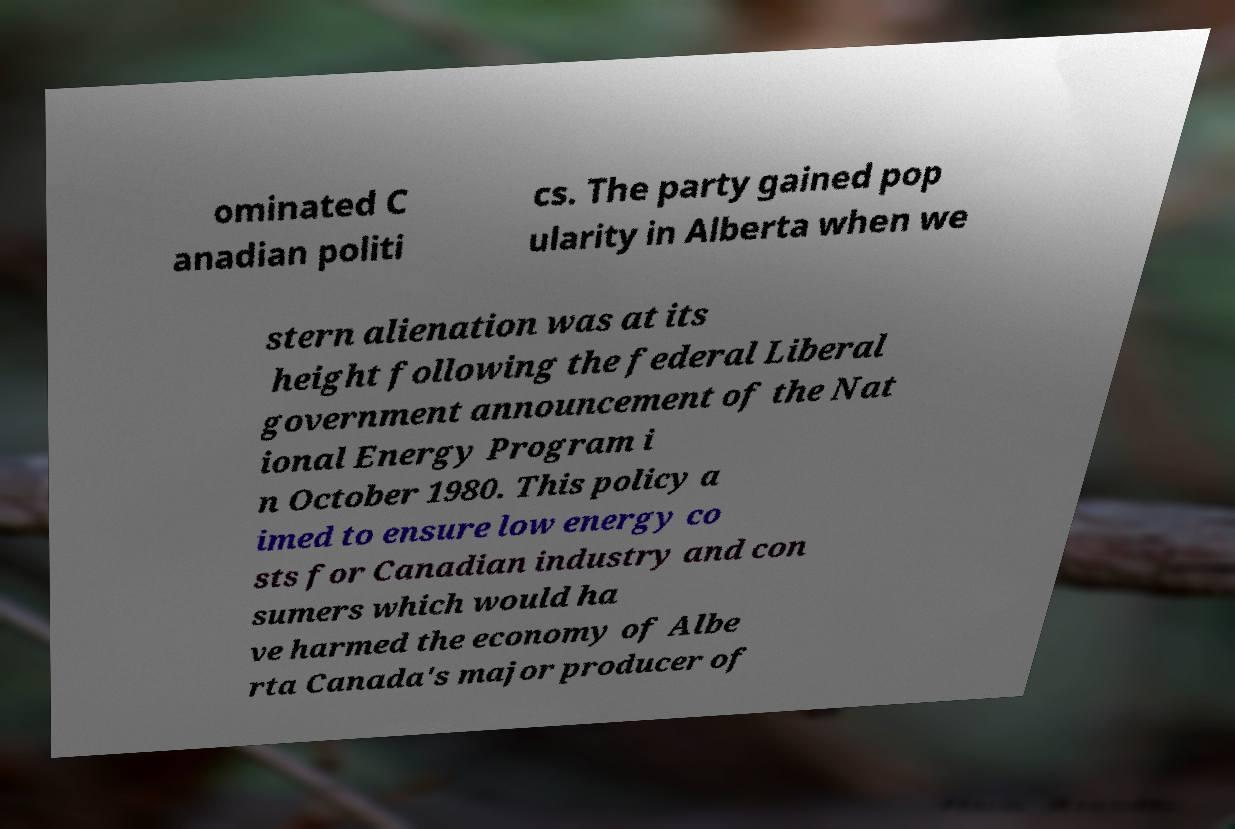I need the written content from this picture converted into text. Can you do that? ominated C anadian politi cs. The party gained pop ularity in Alberta when we stern alienation was at its height following the federal Liberal government announcement of the Nat ional Energy Program i n October 1980. This policy a imed to ensure low energy co sts for Canadian industry and con sumers which would ha ve harmed the economy of Albe rta Canada's major producer of 